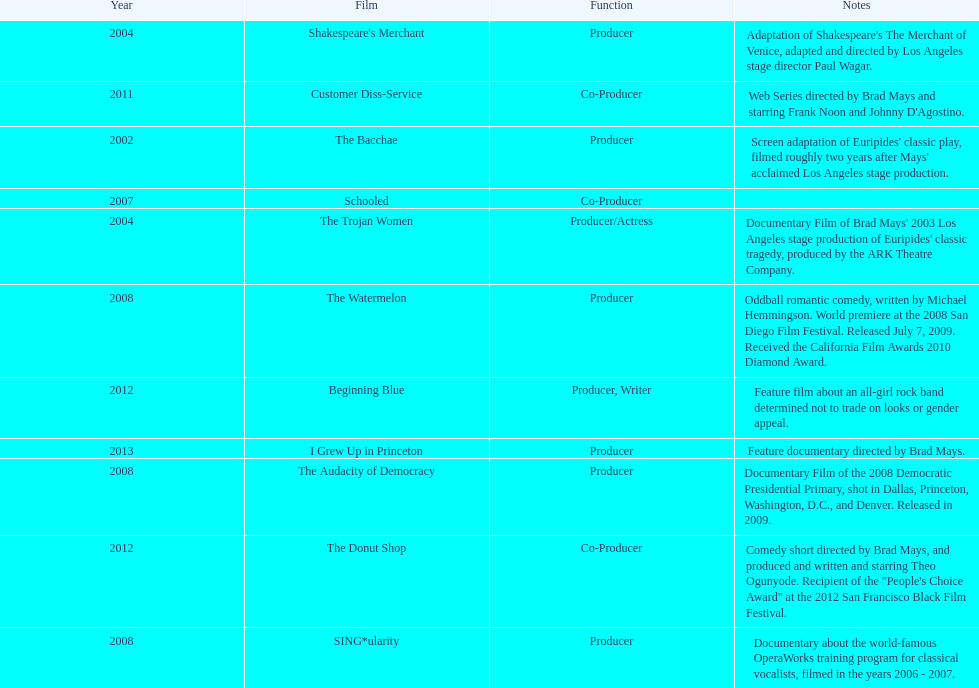What documentary film was produced before the year 2011 but after 2008? The Audacity of Democracy. 